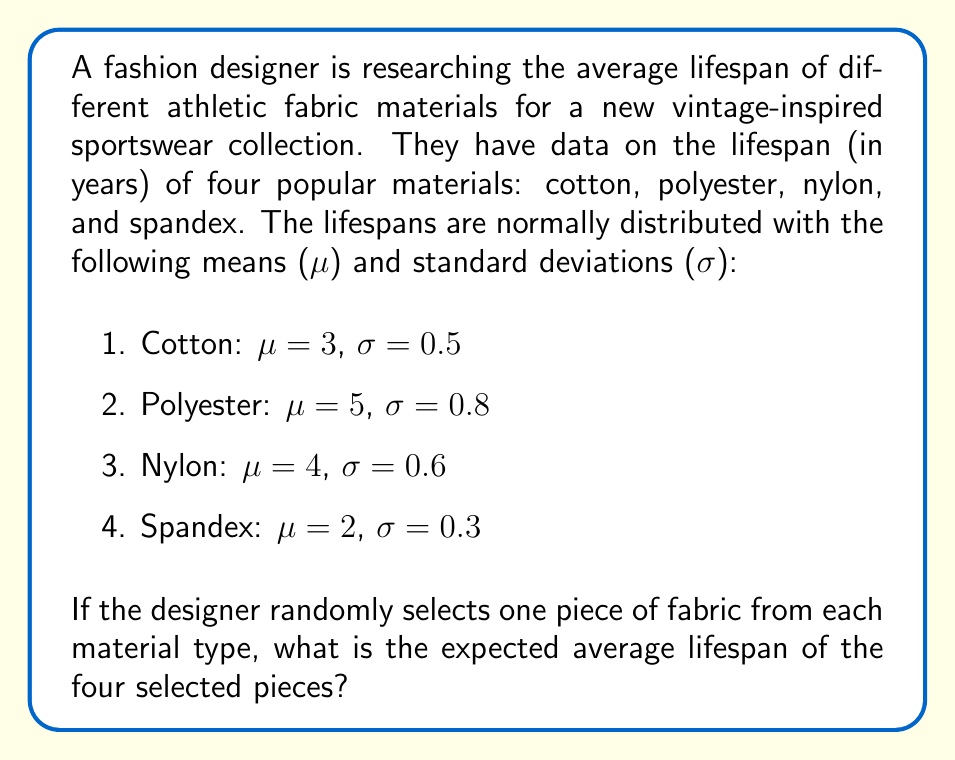Can you solve this math problem? To solve this problem, we need to calculate the expected value of the average lifespan of the four randomly selected pieces. Since we're dealing with the average of multiple random variables, we can use the linearity of expectation property.

Step 1: Calculate the expected value for each material.
The expected value of a normally distributed variable is equal to its mean ($\mu$).

E(Cotton) = 3 years
E(Polyester) = 5 years
E(Nylon) = 4 years
E(Spandex) = 2 years

Step 2: Calculate the sum of the expected values.
$$\text{Sum of E} = 3 + 5 + 4 + 2 = 14 \text{ years}$$

Step 3: Calculate the average of the expected values.
Since we're looking for the average lifespan of the four pieces, we divide the sum by 4.

$$\text{Expected Average} = \frac{\text{Sum of E}}{4} = \frac{14}{4} = 3.5 \text{ years}$$

Therefore, the expected average lifespan of the four randomly selected pieces is 3.5 years.
Answer: 3.5 years 